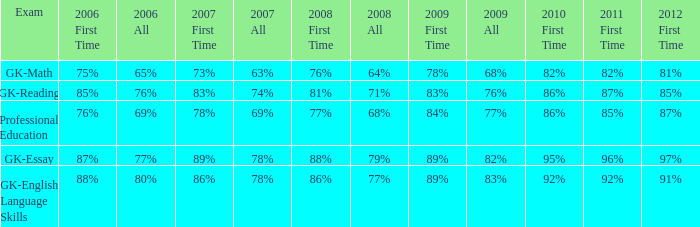What is the percentage for all 2008 when all in 2007 is 69%? 68%. 